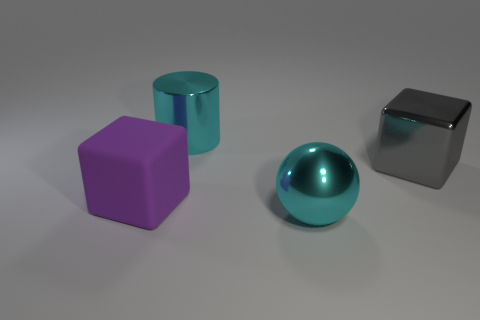Add 2 large rubber cubes. How many objects exist? 6 Subtract all spheres. How many objects are left? 3 Add 3 large rubber objects. How many large rubber objects are left? 4 Add 1 large gray shiny spheres. How many large gray shiny spheres exist? 1 Subtract 0 blue cubes. How many objects are left? 4 Subtract all rubber objects. Subtract all large cyan things. How many objects are left? 1 